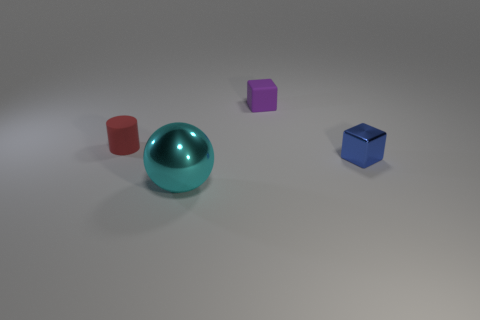Is the number of cyan objects that are right of the big metal thing less than the number of small things?
Provide a short and direct response. Yes. Do the small shiny thing and the small red matte thing have the same shape?
Offer a terse response. No. The other metallic object that is the same shape as the purple object is what color?
Provide a short and direct response. Blue. What number of things are tiny cubes in front of the cylinder or purple rubber balls?
Provide a short and direct response. 1. There is a block in front of the purple matte thing; what size is it?
Provide a short and direct response. Small. Is the number of small purple rubber blocks less than the number of tiny green matte balls?
Offer a terse response. No. Do the object on the right side of the purple cube and the small red cylinder that is behind the big shiny sphere have the same material?
Offer a very short reply. No. What is the shape of the small rubber thing that is on the right side of the metallic object in front of the shiny object behind the large cyan shiny sphere?
Your answer should be very brief. Cube. How many balls have the same material as the small red cylinder?
Ensure brevity in your answer.  0. There is a small object in front of the tiny red cylinder; how many metallic things are in front of it?
Give a very brief answer. 1. 